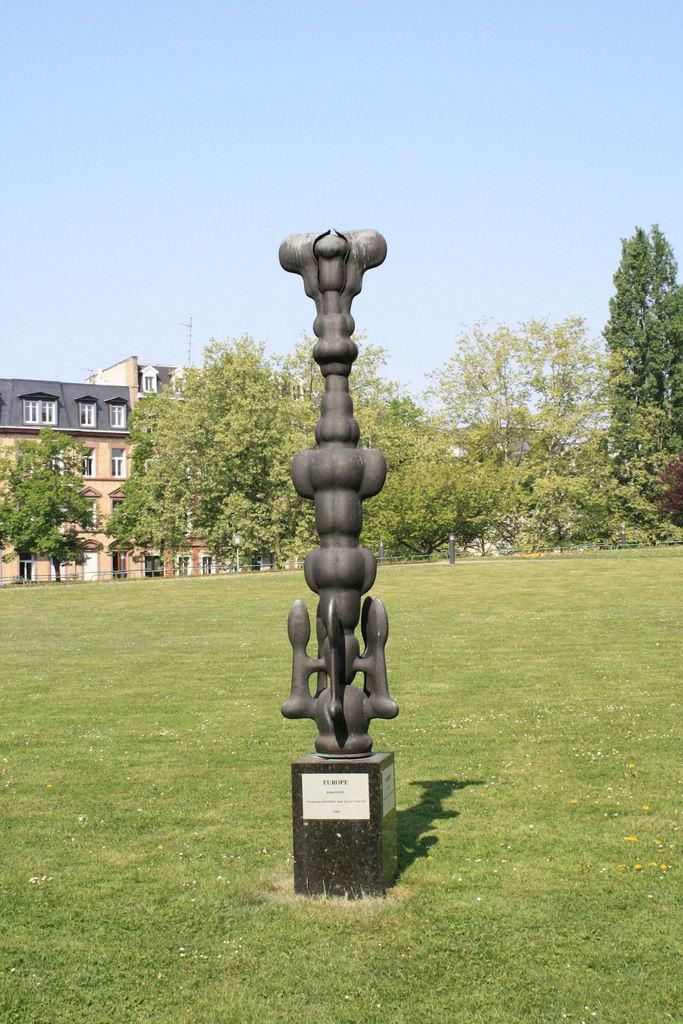What is the main subject in the image? There is a statue in the image. How is the statue positioned in the image? The statue is on a pedestal. What type of natural elements can be seen in the image? There are trees in the image. What part of the environment is visible in the image? The ground is visible in the image. What type of man-made structures are present in the image? There are buildings in the image. What is visible in the background of the image? The sky is visible in the image. What type of thunder can be heard in the image? There is no sound present in the image, so it is not possible to determine if any thunder can be heard. 